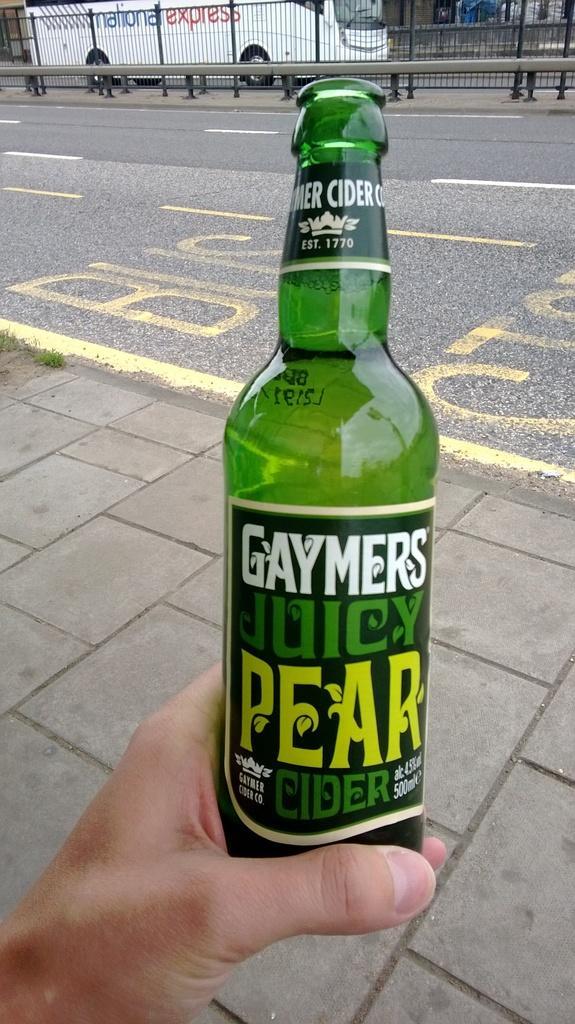Could you give a brief overview of what you see in this image? The person is holding a green bottle in his left hand and there is a white bus in the background. 